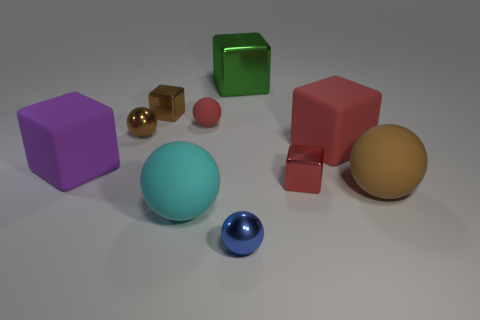Subtract all blue balls. How many balls are left? 4 Subtract all red spheres. How many spheres are left? 4 Subtract all gray balls. Subtract all brown blocks. How many balls are left? 5 Subtract 0 brown cylinders. How many objects are left? 10 Subtract all brown things. Subtract all big cyan spheres. How many objects are left? 6 Add 6 large matte objects. How many large matte objects are left? 10 Add 1 big cyan rubber objects. How many big cyan rubber objects exist? 2 